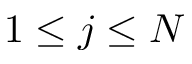Convert formula to latex. <formula><loc_0><loc_0><loc_500><loc_500>1 \leq j \leq N</formula> 